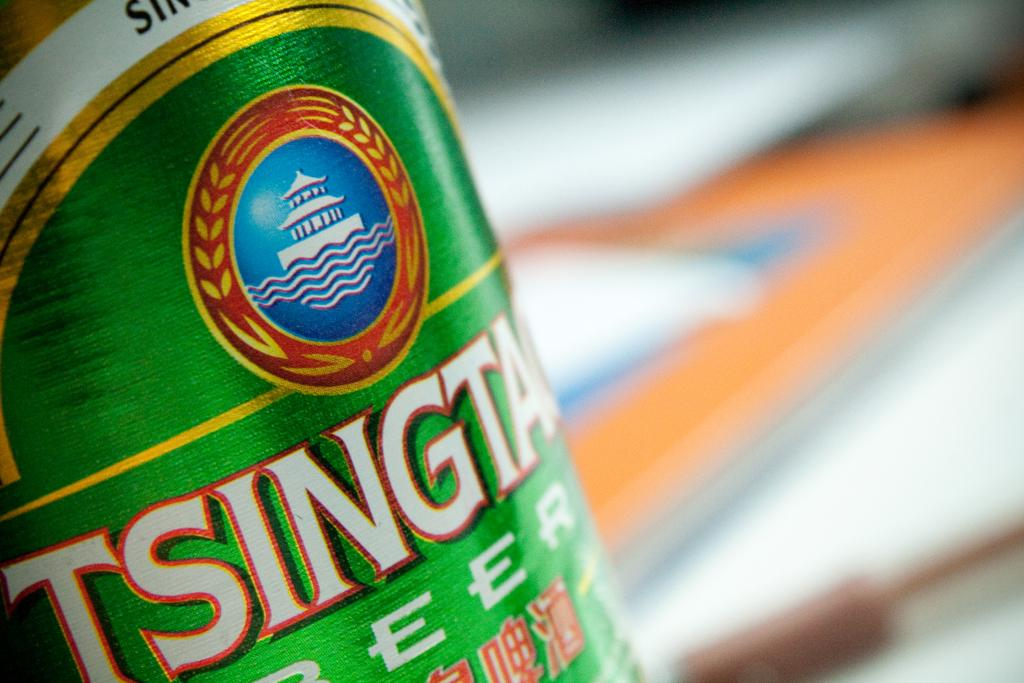Provide a one-sentence caption for the provided image. Asian style beer in a green can with Tsingta part of the brand name. 